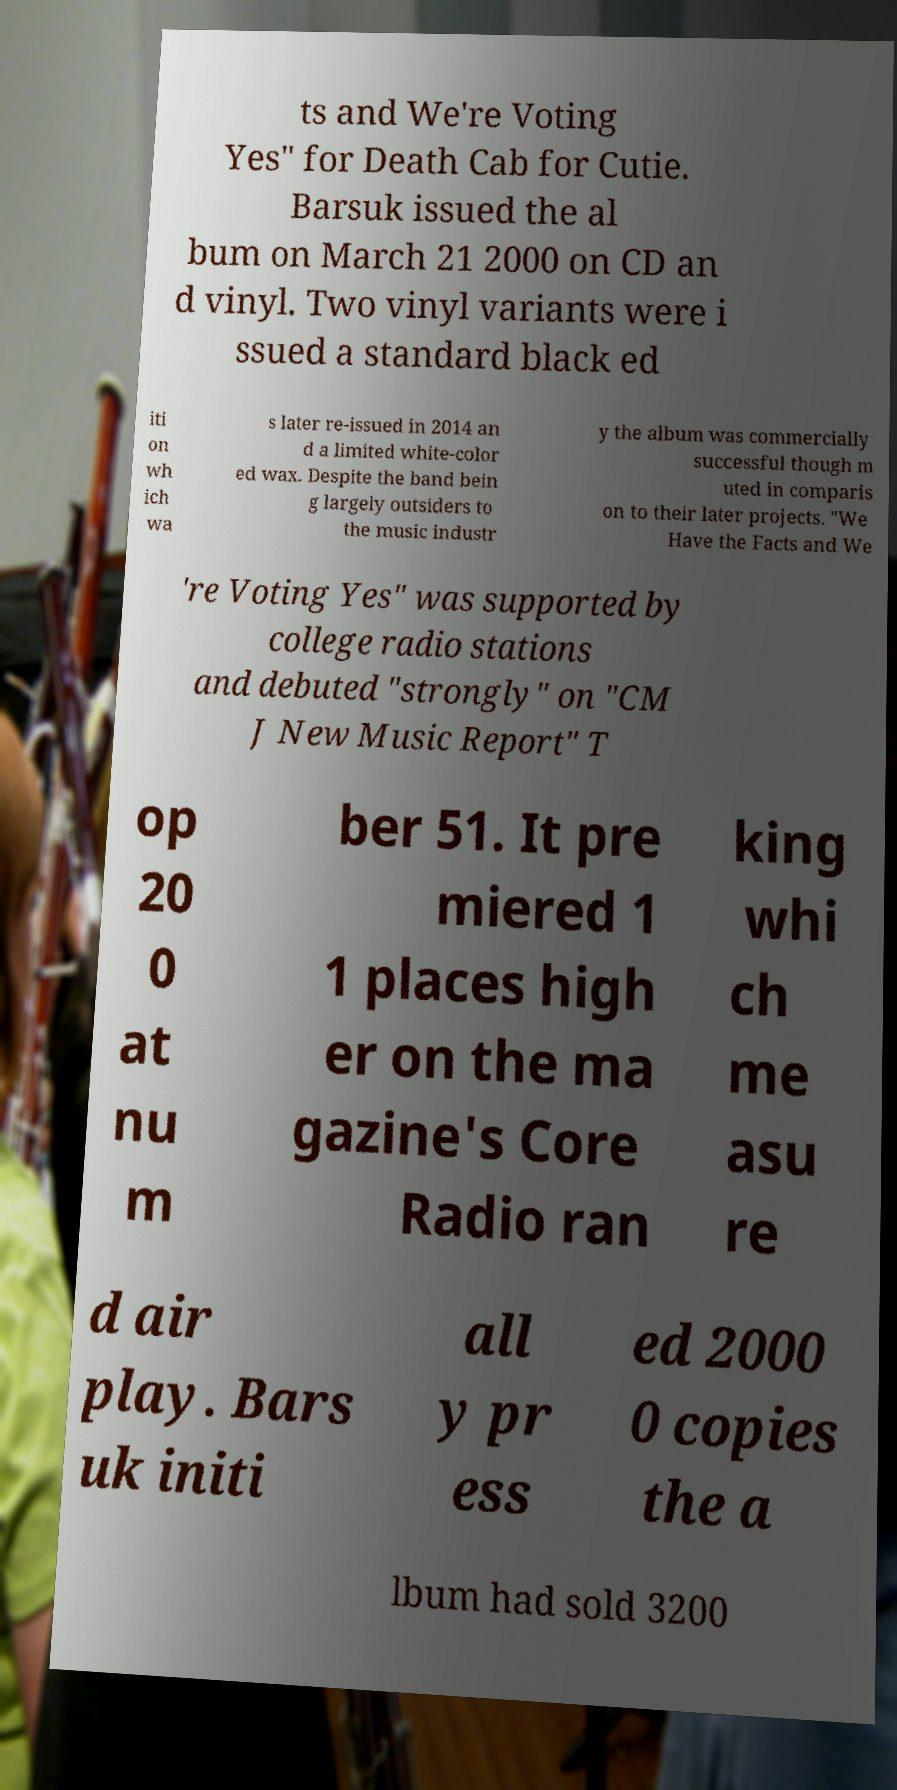What messages or text are displayed in this image? I need them in a readable, typed format. ts and We're Voting Yes" for Death Cab for Cutie. Barsuk issued the al bum on March 21 2000 on CD an d vinyl. Two vinyl variants were i ssued a standard black ed iti on wh ich wa s later re-issued in 2014 an d a limited white-color ed wax. Despite the band bein g largely outsiders to the music industr y the album was commercially successful though m uted in comparis on to their later projects. "We Have the Facts and We 're Voting Yes" was supported by college radio stations and debuted "strongly" on "CM J New Music Report" T op 20 0 at nu m ber 51. It pre miered 1 1 places high er on the ma gazine's Core Radio ran king whi ch me asu re d air play. Bars uk initi all y pr ess ed 2000 0 copies the a lbum had sold 3200 